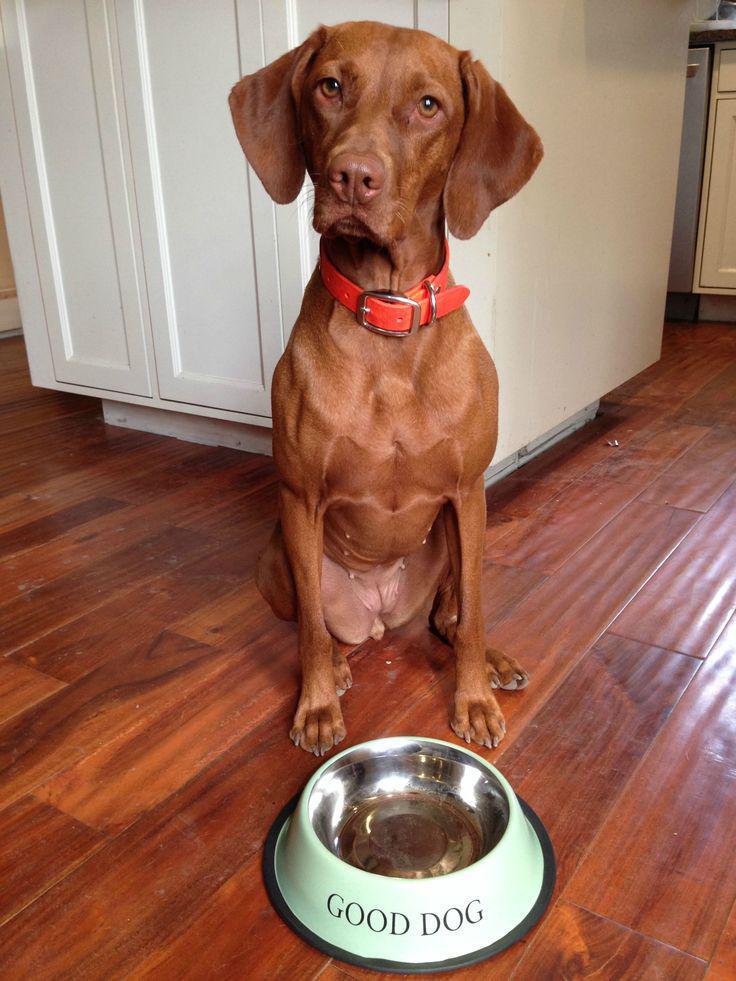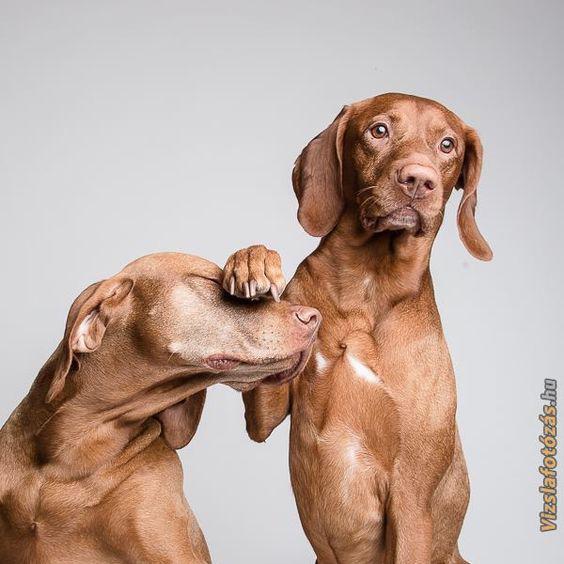The first image is the image on the left, the second image is the image on the right. Evaluate the accuracy of this statement regarding the images: "Each image includes a red-orange dog with floppy ears in an upright sitting position, the dog depicted in the left image is facing forward, and a dog depicted in the right image has something on top of its muzzle.". Is it true? Answer yes or no. Yes. 